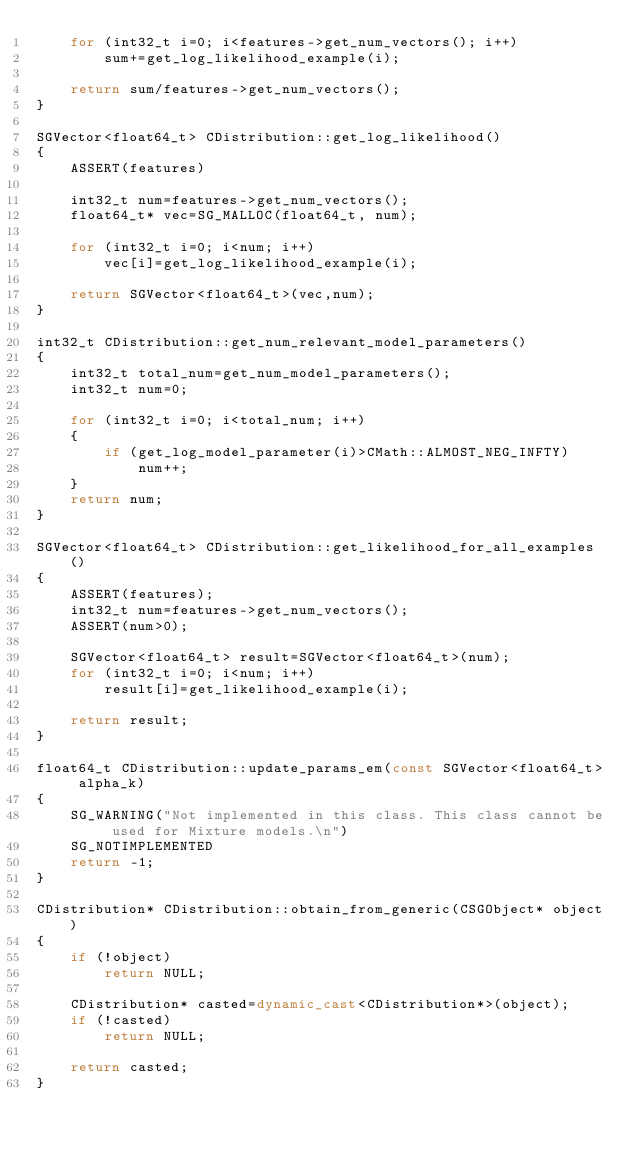Convert code to text. <code><loc_0><loc_0><loc_500><loc_500><_C++_>	for (int32_t i=0; i<features->get_num_vectors(); i++)
		sum+=get_log_likelihood_example(i);

	return sum/features->get_num_vectors();
}

SGVector<float64_t> CDistribution::get_log_likelihood()
{
	ASSERT(features)

	int32_t num=features->get_num_vectors();
	float64_t* vec=SG_MALLOC(float64_t, num);

	for (int32_t i=0; i<num; i++)
		vec[i]=get_log_likelihood_example(i);

	return SGVector<float64_t>(vec,num);
}

int32_t CDistribution::get_num_relevant_model_parameters()
{
	int32_t total_num=get_num_model_parameters();
	int32_t num=0;

	for (int32_t i=0; i<total_num; i++)
	{
		if (get_log_model_parameter(i)>CMath::ALMOST_NEG_INFTY)
			num++;
	}
	return num;
}

SGVector<float64_t> CDistribution::get_likelihood_for_all_examples()
{
	ASSERT(features);
	int32_t num=features->get_num_vectors();
	ASSERT(num>0);

	SGVector<float64_t> result=SGVector<float64_t>(num);
	for (int32_t i=0; i<num; i++)
		result[i]=get_likelihood_example(i);

	return result;
}

float64_t CDistribution::update_params_em(const SGVector<float64_t> alpha_k)
{
	SG_WARNING("Not implemented in this class. This class cannot be used for Mixture models.\n")
	SG_NOTIMPLEMENTED
	return -1;
}

CDistribution* CDistribution::obtain_from_generic(CSGObject* object)
{
	if (!object)
		return NULL;

	CDistribution* casted=dynamic_cast<CDistribution*>(object);
	if (!casted)
		return NULL;

	return casted;
}
</code> 